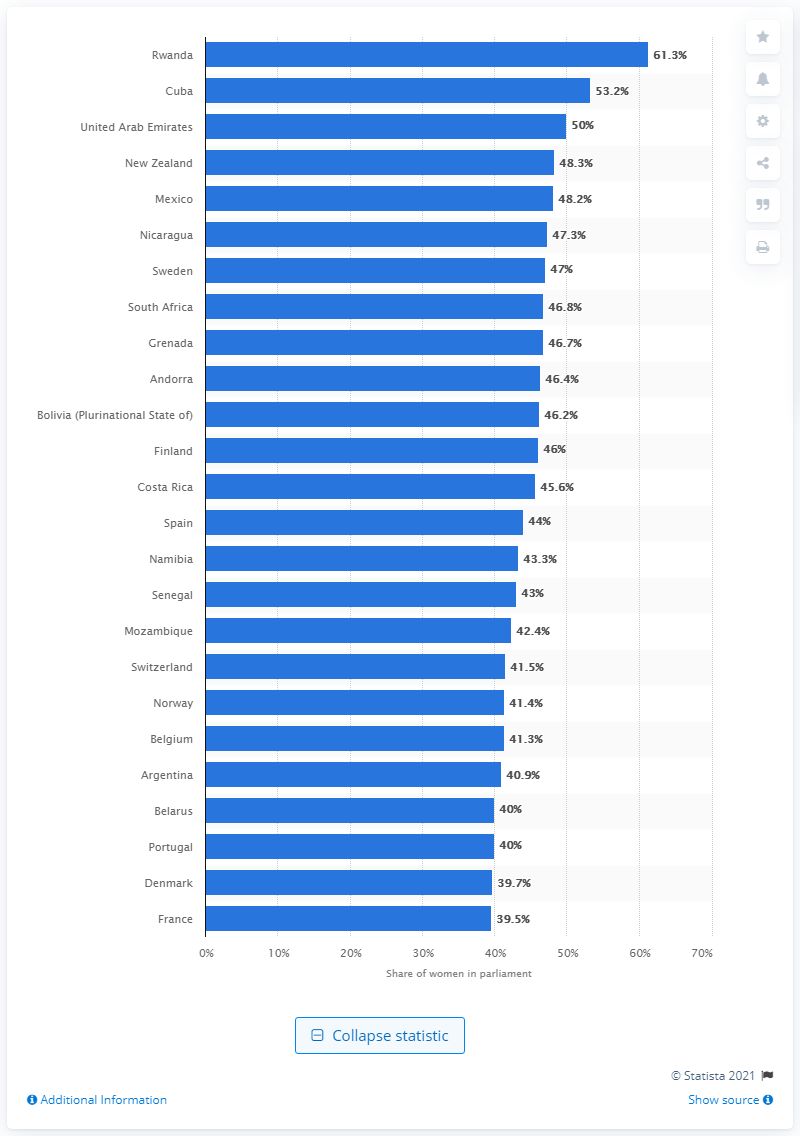Outline some significant characteristics in this image. As of December 2020, 61.3% of the members of the Rwandan parliament were women. 